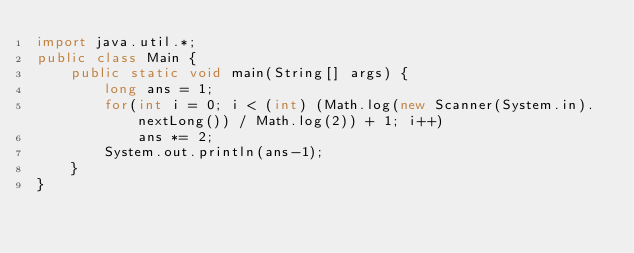<code> <loc_0><loc_0><loc_500><loc_500><_Java_>import java.util.*;
public class Main {
	public static void main(String[] args) {
		long ans = 1;
		for(int i = 0; i < (int) (Math.log(new Scanner(System.in).nextLong()) / Math.log(2)) + 1; i++)
			ans *= 2;
		System.out.println(ans-1);
	}
}</code> 